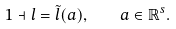<formula> <loc_0><loc_0><loc_500><loc_500>1 \dashv l = \tilde { l } ( a ) , \quad a \in \mathbb { R } ^ { s } .</formula> 